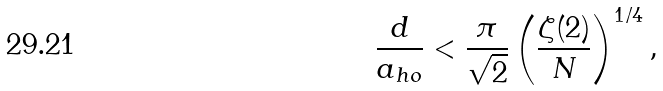<formula> <loc_0><loc_0><loc_500><loc_500>\frac { d } { a _ { h o } } < \frac { \pi } { \sqrt { 2 } } \left ( \frac { \zeta ( 2 ) } { N } \right ) ^ { 1 / 4 } ,</formula> 